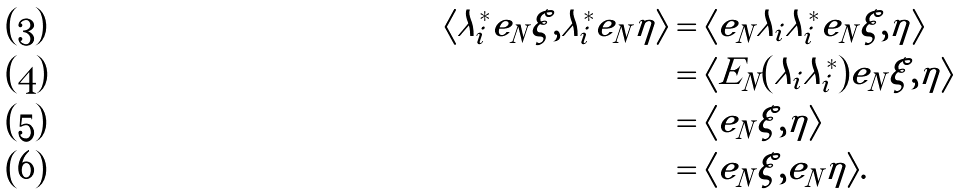<formula> <loc_0><loc_0><loc_500><loc_500>\langle \lambda _ { i } ^ { * } e _ { N } \xi , \lambda _ { i } ^ { * } e _ { N } \eta \rangle & = \langle e _ { N } \lambda _ { i } \lambda _ { i } ^ { * } e _ { N } \xi , \eta \rangle \\ & = \langle E _ { N } ( \lambda _ { i } \lambda _ { i } ^ { * } ) e _ { N } \xi , \eta \rangle \\ & = \langle e _ { N } \xi , \eta \rangle \\ & = \langle e _ { N } \xi , e _ { N } \eta \rangle .</formula> 